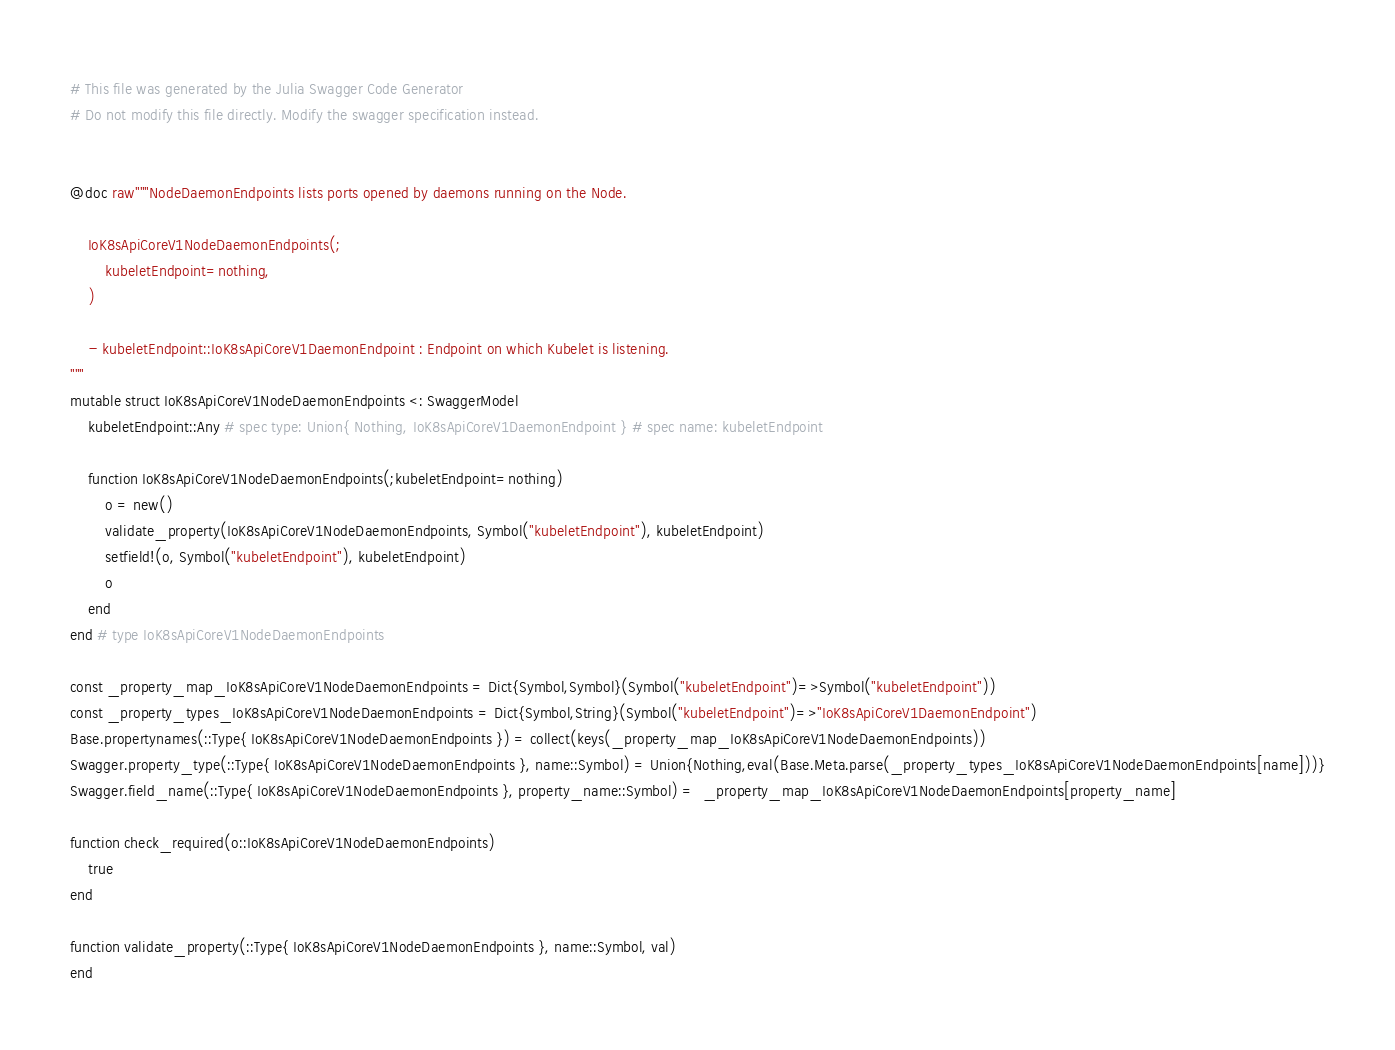Convert code to text. <code><loc_0><loc_0><loc_500><loc_500><_Julia_># This file was generated by the Julia Swagger Code Generator
# Do not modify this file directly. Modify the swagger specification instead.


@doc raw"""NodeDaemonEndpoints lists ports opened by daemons running on the Node.

    IoK8sApiCoreV1NodeDaemonEndpoints(;
        kubeletEndpoint=nothing,
    )

    - kubeletEndpoint::IoK8sApiCoreV1DaemonEndpoint : Endpoint on which Kubelet is listening.
"""
mutable struct IoK8sApiCoreV1NodeDaemonEndpoints <: SwaggerModel
    kubeletEndpoint::Any # spec type: Union{ Nothing, IoK8sApiCoreV1DaemonEndpoint } # spec name: kubeletEndpoint

    function IoK8sApiCoreV1NodeDaemonEndpoints(;kubeletEndpoint=nothing)
        o = new()
        validate_property(IoK8sApiCoreV1NodeDaemonEndpoints, Symbol("kubeletEndpoint"), kubeletEndpoint)
        setfield!(o, Symbol("kubeletEndpoint"), kubeletEndpoint)
        o
    end
end # type IoK8sApiCoreV1NodeDaemonEndpoints

const _property_map_IoK8sApiCoreV1NodeDaemonEndpoints = Dict{Symbol,Symbol}(Symbol("kubeletEndpoint")=>Symbol("kubeletEndpoint"))
const _property_types_IoK8sApiCoreV1NodeDaemonEndpoints = Dict{Symbol,String}(Symbol("kubeletEndpoint")=>"IoK8sApiCoreV1DaemonEndpoint")
Base.propertynames(::Type{ IoK8sApiCoreV1NodeDaemonEndpoints }) = collect(keys(_property_map_IoK8sApiCoreV1NodeDaemonEndpoints))
Swagger.property_type(::Type{ IoK8sApiCoreV1NodeDaemonEndpoints }, name::Symbol) = Union{Nothing,eval(Base.Meta.parse(_property_types_IoK8sApiCoreV1NodeDaemonEndpoints[name]))}
Swagger.field_name(::Type{ IoK8sApiCoreV1NodeDaemonEndpoints }, property_name::Symbol) =  _property_map_IoK8sApiCoreV1NodeDaemonEndpoints[property_name]

function check_required(o::IoK8sApiCoreV1NodeDaemonEndpoints)
    true
end

function validate_property(::Type{ IoK8sApiCoreV1NodeDaemonEndpoints }, name::Symbol, val)
end
</code> 